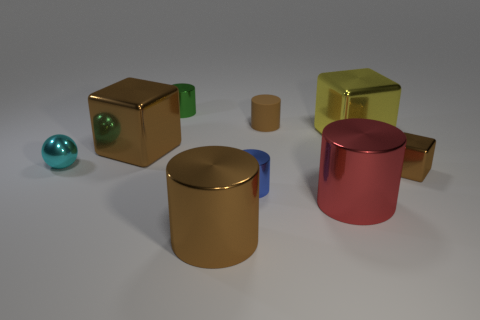There is a tiny rubber thing that is the same color as the small block; what is its shape?
Keep it short and to the point. Cylinder. The tiny shiny cylinder in front of the cyan metal ball is what color?
Make the answer very short. Blue. What number of objects are brown objects in front of the rubber thing or cubes?
Your answer should be compact. 4. What is the color of the metal block that is the same size as the yellow object?
Offer a terse response. Brown. Is the number of brown blocks that are in front of the brown metal cylinder greater than the number of large brown metallic cylinders?
Provide a succinct answer. No. The large thing that is both behind the large red shiny cylinder and to the left of the yellow cube is made of what material?
Ensure brevity in your answer.  Metal. There is a tiny shiny cylinder that is in front of the tiny green metallic thing; does it have the same color as the small cylinder behind the brown matte thing?
Offer a very short reply. No. How many other objects are there of the same size as the brown metallic cylinder?
Make the answer very short. 3. There is a tiny brown thing in front of the large thing to the right of the big red metal cylinder; is there a big brown shiny cube behind it?
Provide a succinct answer. Yes. Are the tiny cylinder in front of the cyan sphere and the tiny block made of the same material?
Make the answer very short. Yes. 